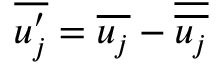Convert formula to latex. <formula><loc_0><loc_0><loc_500><loc_500>\overline { { u _ { j } ^ { \prime } } } = \overline { { u _ { j } } } - \overline { { \overline { { u _ { j } } } } }</formula> 